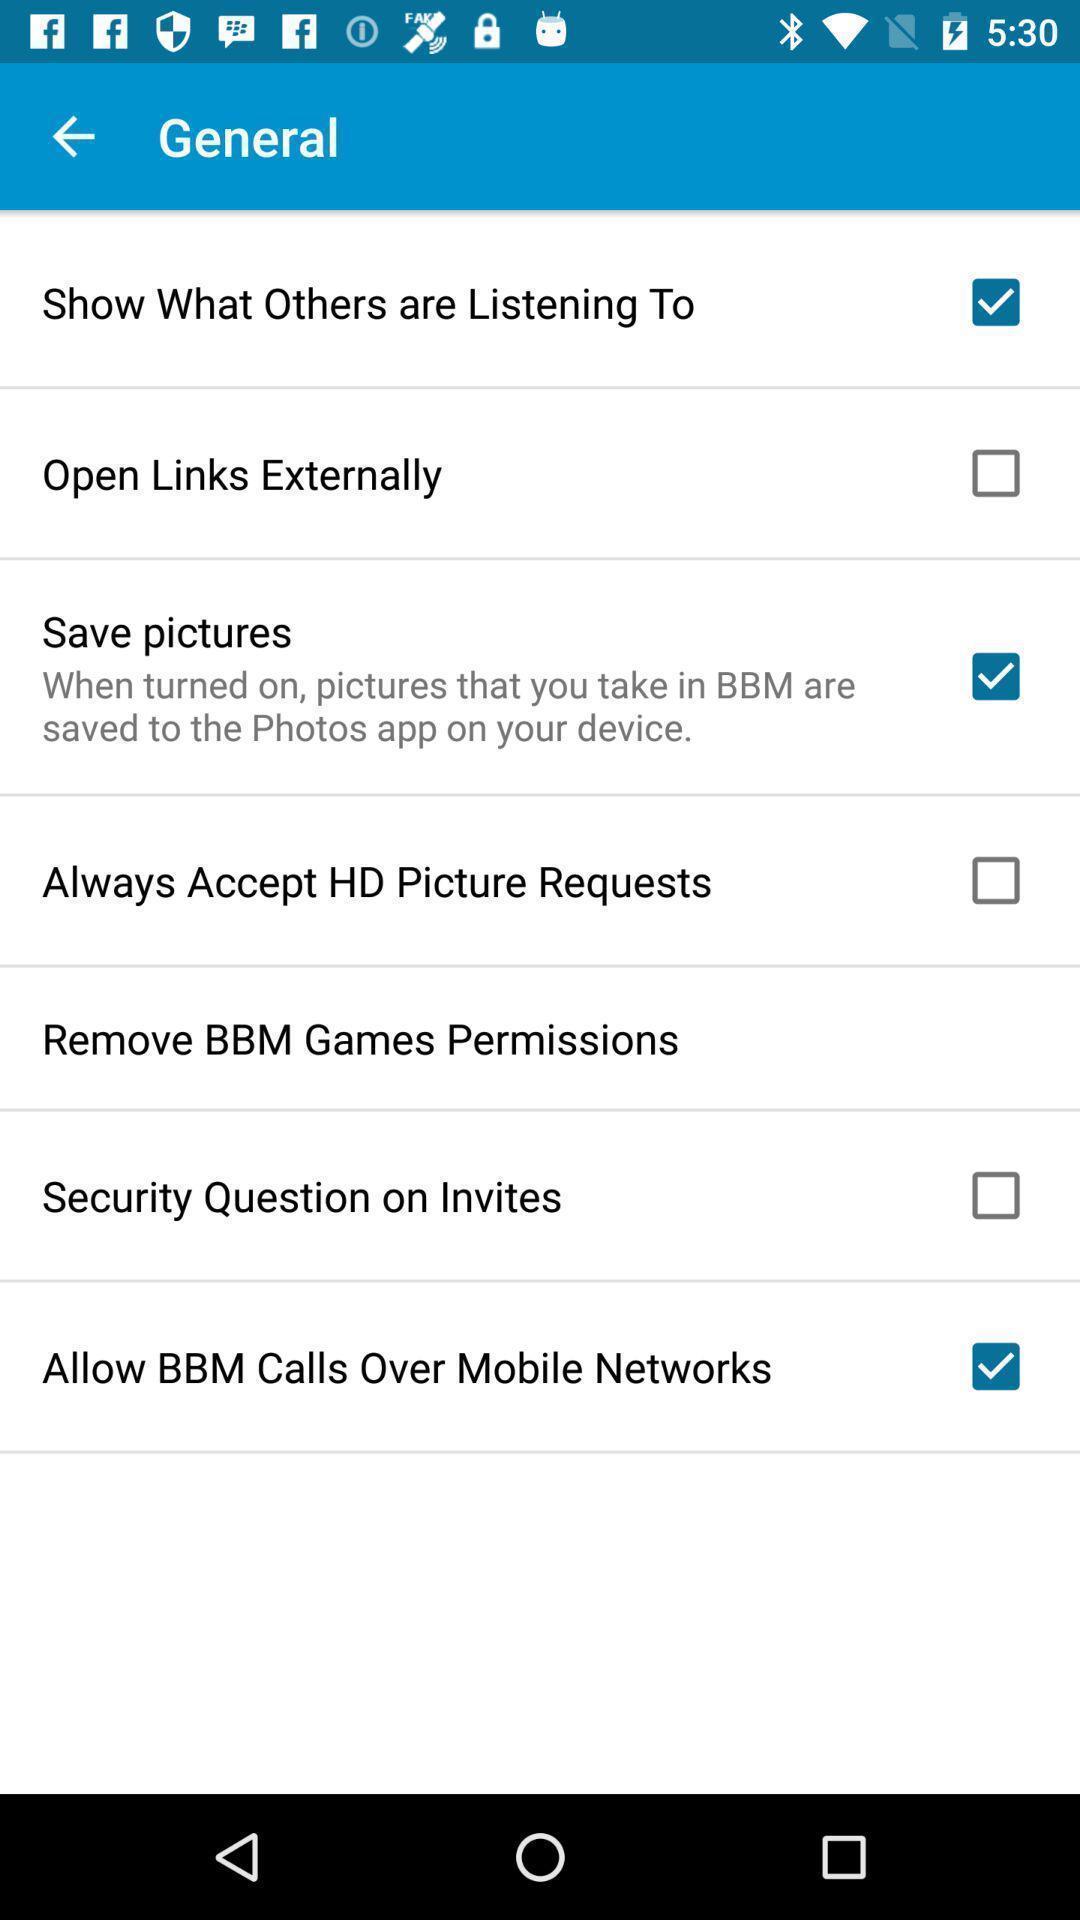What is the overall content of this screenshot? Screen displaying list of general settings. 